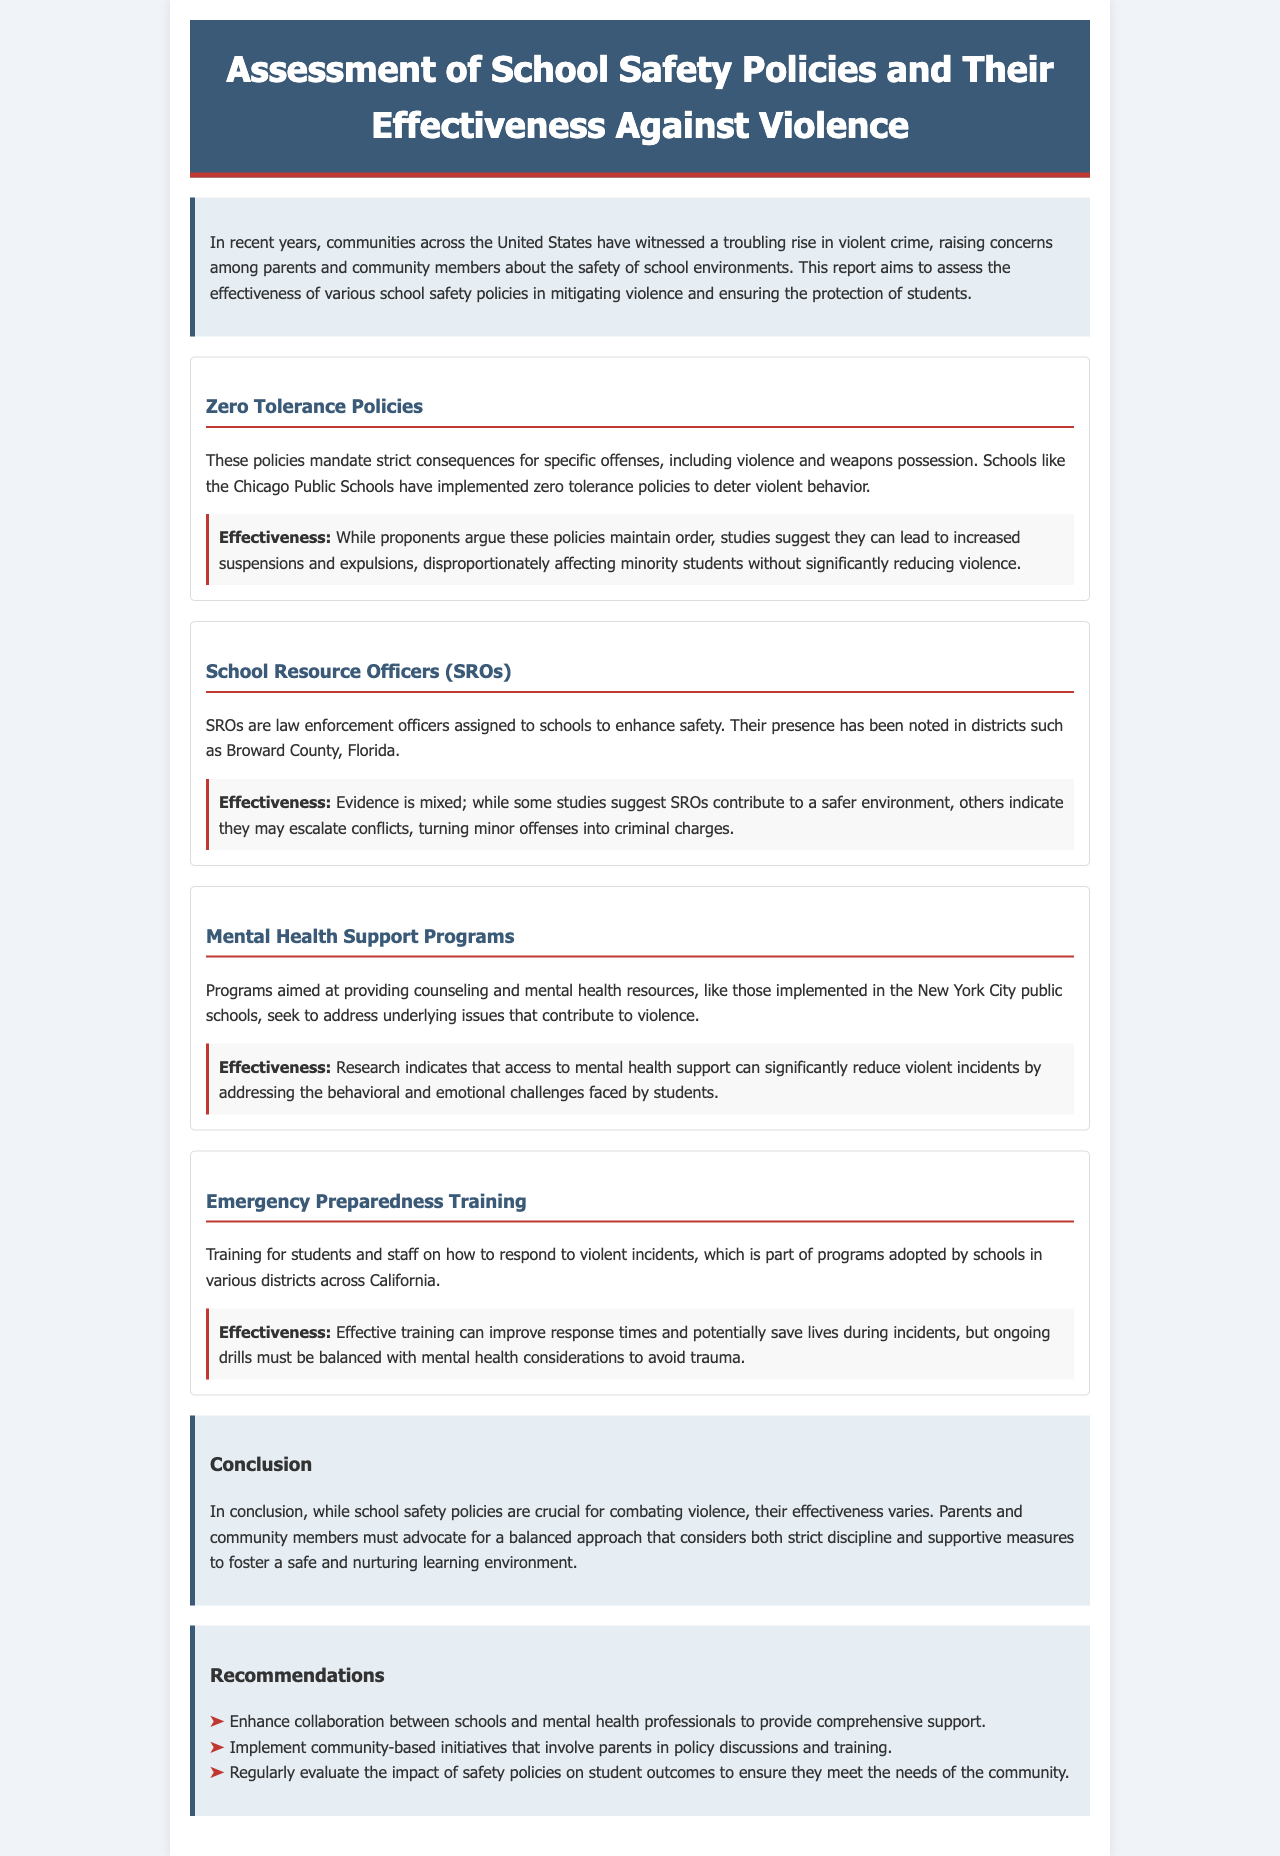What is the title of the report? The title of the report is listed at the top of the document in the header section.
Answer: Assessment of School Safety Policies and Their Effectiveness Against Violence What is one example of a school safety policy discussed? The document lists specific school safety policies under a designated section, each with descriptions.
Answer: Zero Tolerance Policies Which school district is mentioned for implementing School Resource Officers? The report explicitly mentions the district in connection with the implementation of School Resource Officers.
Answer: Broward County What is the reported effectiveness of Mental Health Support Programs? The effectiveness of different policies is summarized in specific sections, particularly focusing on mental health support.
Answer: Reduce violent incidents Which state is mentioned regarding Emergency Preparedness Training? The content specifies states where certain policies have been adopted, focusing on emergency training.
Answer: California What is one recommendation made in the report? Recommendations are provided in a dedicated section at the end of the report, outlining actions to improve safety measures.
Answer: Enhance collaboration between schools and mental health professionals What negative effect can Zero Tolerance Policies lead to? The report points out potential issues associated with specific policies, highlighting significant concerns for certain groups.
Answer: Increased suspensions and expulsions What overarching concern does the introduction address? The introduction sets the context for the document by discussing a broad issue affecting communities and schools.
Answer: Rise in violent crime 